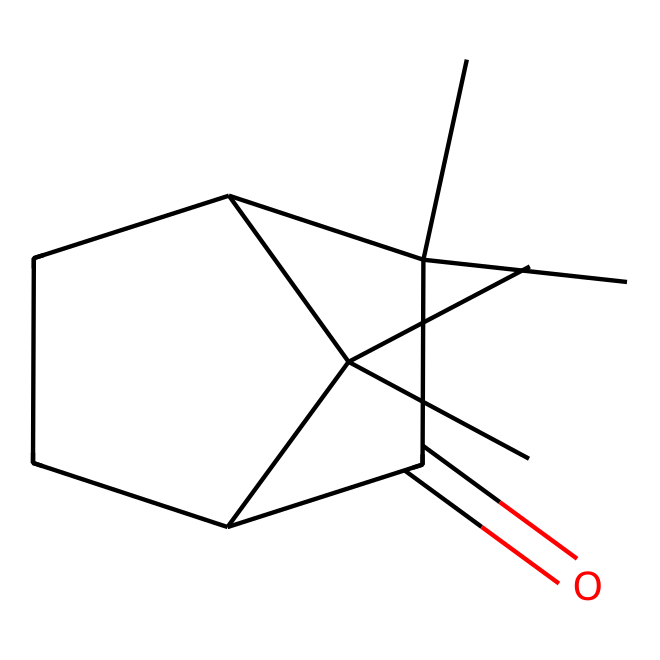What is the molecular formula of camphor? To find the molecular formula, we can count the number of carbon (C), hydrogen (H), and oxygen (O) atoms in the SMILES representation. From the structure, we determine there are 10 carbon atoms, 16 hydrogen atoms, and 1 oxygen atom. Therefore, the molecular formula is C10H16O.
Answer: C10H16O How many rings are present in the structure of camphor? By examining the SMILES representation, we can identify that the presence of numbers indicates ring closures. The structure has two numbers (1 and 2), indicating that there are two ring structures formed in the camphor molecule.
Answer: 2 What type of functional group is present in camphor? The SMILES indicates the presence of a carbonyl group (C=O) characteristic of ketones. In camphor, we can see that this carbonyl is part of the structure which is typical for ketones.
Answer: carbonyl Is camphor a saturated or unsaturated compound? To determine saturation, we count the number of double bonds or rings. The presence of a C=O bond and ring structures indicates that there are no double bonds between carbon atoms outside the ketone, classifying camphor as a saturated compound.
Answer: saturated What is the total number of hydrogen atoms in camphor? The hydrogen atoms can be directly counted from the determined molecular formula C10H16O, where the subscript '16' denotes the total number of hydrogen atoms present in the compound camphor.
Answer: 16 Which type of isomer does camphor exemplify? Camphor is an example of a ketonic compound, specifically a bicyclic ketone, due to its two-ring system and the presence of a carbonyl group. This classification helps highlight its specific placement in the isomer category among ketones.
Answer: bicyclic ketone 